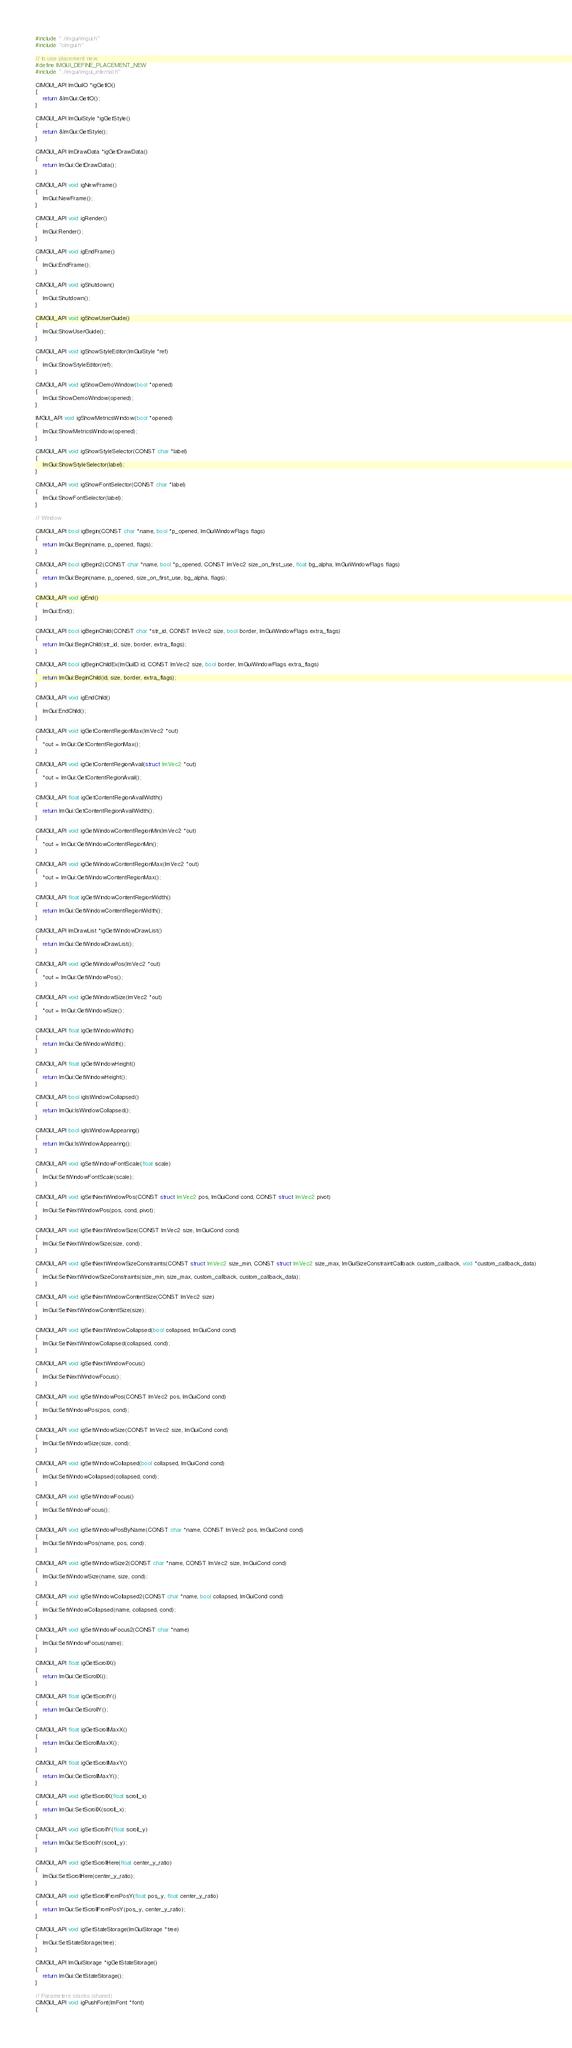<code> <loc_0><loc_0><loc_500><loc_500><_C++_>
#include "../imgui/imgui.h"
#include "cimgui.h"

// to use placement new
#define IMGUI_DEFINE_PLACEMENT_NEW
#include "../imgui/imgui_internal.h"

CIMGUI_API ImGuiIO *igGetIO()
{
    return &ImGui::GetIO();
}

CIMGUI_API ImGuiStyle *igGetStyle()
{
    return &ImGui::GetStyle();
}

CIMGUI_API ImDrawData *igGetDrawData()
{
    return ImGui::GetDrawData();
}

CIMGUI_API void igNewFrame()
{
    ImGui::NewFrame();
}

CIMGUI_API void igRender()
{
    ImGui::Render();
}

CIMGUI_API void igEndFrame()
{
    ImGui::EndFrame();
}

CIMGUI_API void igShutdown()
{
    ImGui::Shutdown();
}

CIMGUI_API void igShowUserGuide()
{
    ImGui::ShowUserGuide();
}

CIMGUI_API void igShowStyleEditor(ImGuiStyle *ref)
{
    ImGui::ShowStyleEditor(ref);
}

CIMGUI_API void igShowDemoWindow(bool *opened)
{
    ImGui::ShowDemoWindow(opened);
}

IMGUI_API void igShowMetricsWindow(bool *opened)
{
    ImGui::ShowMetricsWindow(opened);
}

CIMGUI_API void igShowStyleSelector(CONST char *label)
{
    ImGui::ShowStyleSelector(label);
}

CIMGUI_API void igShowFontSelector(CONST char *label)
{
    ImGui::ShowFontSelector(label);
}

// Window

CIMGUI_API bool igBegin(CONST char *name, bool *p_opened, ImGuiWindowFlags flags)
{
    return ImGui::Begin(name, p_opened, flags);
}

CIMGUI_API bool igBegin2(CONST char *name, bool *p_opened, CONST ImVec2 size_on_first_use, float bg_alpha, ImGuiWindowFlags flags)
{
    return ImGui::Begin(name, p_opened, size_on_first_use, bg_alpha, flags);
}

CIMGUI_API void igEnd()
{
    ImGui::End();
}

CIMGUI_API bool igBeginChild(CONST char *str_id, CONST ImVec2 size, bool border, ImGuiWindowFlags extra_flags)
{
    return ImGui::BeginChild(str_id, size, border, extra_flags);
}

CIMGUI_API bool igBeginChildEx(ImGuiID id, CONST ImVec2 size, bool border, ImGuiWindowFlags extra_flags)
{
    return ImGui::BeginChild(id, size, border, extra_flags);
}

CIMGUI_API void igEndChild()
{
    ImGui::EndChild();
}

CIMGUI_API void igGetContentRegionMax(ImVec2 *out)
{
    *out = ImGui::GetContentRegionMax();
}

CIMGUI_API void igGetContentRegionAvail(struct ImVec2 *out)
{
    *out = ImGui::GetContentRegionAvail();
}

CIMGUI_API float igGetContentRegionAvailWidth()
{
    return ImGui::GetContentRegionAvailWidth();
}

CIMGUI_API void igGetWindowContentRegionMin(ImVec2 *out)
{
    *out = ImGui::GetWindowContentRegionMin();
}

CIMGUI_API void igGetWindowContentRegionMax(ImVec2 *out)
{
    *out = ImGui::GetWindowContentRegionMax();
}

CIMGUI_API float igGetWindowContentRegionWidth()
{
    return ImGui::GetWindowContentRegionWidth();
}

CIMGUI_API ImDrawList *igGetWindowDrawList()
{
    return ImGui::GetWindowDrawList();
}

CIMGUI_API void igGetWindowPos(ImVec2 *out)
{
    *out = ImGui::GetWindowPos();
}

CIMGUI_API void igGetWindowSize(ImVec2 *out)
{
    *out = ImGui::GetWindowSize();
}

CIMGUI_API float igGetWindowWidth()
{
    return ImGui::GetWindowWidth();
}

CIMGUI_API float igGetWindowHeight()
{
    return ImGui::GetWindowHeight();
}

CIMGUI_API bool igIsWindowCollapsed()
{
    return ImGui::IsWindowCollapsed();
}

CIMGUI_API bool igIsWindowAppearing()
{
    return ImGui::IsWindowAppearing();
}

CIMGUI_API void igSetWindowFontScale(float scale)
{
    ImGui::SetWindowFontScale(scale);
}

CIMGUI_API void igSetNextWindowPos(CONST struct ImVec2 pos, ImGuiCond cond, CONST struct ImVec2 pivot)
{
    ImGui::SetNextWindowPos(pos, cond, pivot);
}

CIMGUI_API void igSetNextWindowSize(CONST ImVec2 size, ImGuiCond cond)
{
    ImGui::SetNextWindowSize(size, cond);
}

CIMGUI_API void igSetNextWindowSizeConstraints(CONST struct ImVec2 size_min, CONST struct ImVec2 size_max, ImGuiSizeConstraintCallback custom_callback, void *custom_callback_data)
{
    ImGui::SetNextWindowSizeConstraints(size_min, size_max, custom_callback, custom_callback_data);
}

CIMGUI_API void igSetNextWindowContentSize(CONST ImVec2 size)
{
    ImGui::SetNextWindowContentSize(size);
}

CIMGUI_API void igSetNextWindowCollapsed(bool collapsed, ImGuiCond cond)
{
    ImGui::SetNextWindowCollapsed(collapsed, cond);
}

CIMGUI_API void igSetNextWindowFocus()
{
    ImGui::SetNextWindowFocus();
}

CIMGUI_API void igSetWindowPos(CONST ImVec2 pos, ImGuiCond cond)
{
    ImGui::SetWindowPos(pos, cond);
}

CIMGUI_API void igSetWindowSize(CONST ImVec2 size, ImGuiCond cond)
{
    ImGui::SetWindowSize(size, cond);
}

CIMGUI_API void igSetWindowCollapsed(bool collapsed, ImGuiCond cond)
{
    ImGui::SetWindowCollapsed(collapsed, cond);
}

CIMGUI_API void igSetWindowFocus()
{
    ImGui::SetWindowFocus();
}

CIMGUI_API void igSetWindowPosByName(CONST char *name, CONST ImVec2 pos, ImGuiCond cond)
{
    ImGui::SetWindowPos(name, pos, cond);
}

CIMGUI_API void igSetWindowSize2(CONST char *name, CONST ImVec2 size, ImGuiCond cond)
{
    ImGui::SetWindowSize(name, size, cond);
}

CIMGUI_API void igSetWindowCollapsed2(CONST char *name, bool collapsed, ImGuiCond cond)
{
    ImGui::SetWindowCollapsed(name, collapsed, cond);
}

CIMGUI_API void igSetWindowFocus2(CONST char *name)
{
    ImGui::SetWindowFocus(name);
}

CIMGUI_API float igGetScrollX()
{
    return ImGui::GetScrollX();
}

CIMGUI_API float igGetScrollY()
{
    return ImGui::GetScrollY();
}

CIMGUI_API float igGetScrollMaxX()
{
    return ImGui::GetScrollMaxX();
}

CIMGUI_API float igGetScrollMaxY()
{
    return ImGui::GetScrollMaxY();
}

CIMGUI_API void igSetScrollX(float scroll_x)
{
    return ImGui::SetScrollX(scroll_x);
}

CIMGUI_API void igSetScrollY(float scroll_y)
{
    return ImGui::SetScrollY(scroll_y);
}

CIMGUI_API void igSetScrollHere(float center_y_ratio)
{
    ImGui::SetScrollHere(center_y_ratio);
}

CIMGUI_API void igSetScrollFromPosY(float pos_y, float center_y_ratio)
{
    return ImGui::SetScrollFromPosY(pos_y, center_y_ratio);
}

CIMGUI_API void igSetStateStorage(ImGuiStorage *tree)
{
    ImGui::SetStateStorage(tree);
}

CIMGUI_API ImGuiStorage *igGetStateStorage()
{
    return ImGui::GetStateStorage();
}

// Parameters stacks (shared)
CIMGUI_API void igPushFont(ImFont *font)
{</code> 